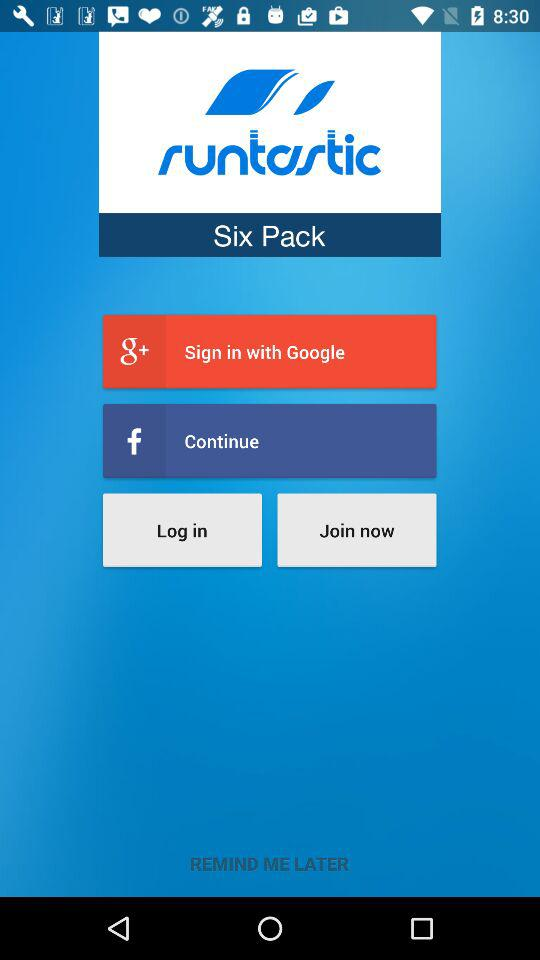What is the name of the application? The name of the application is "runtastic Six Pack". 